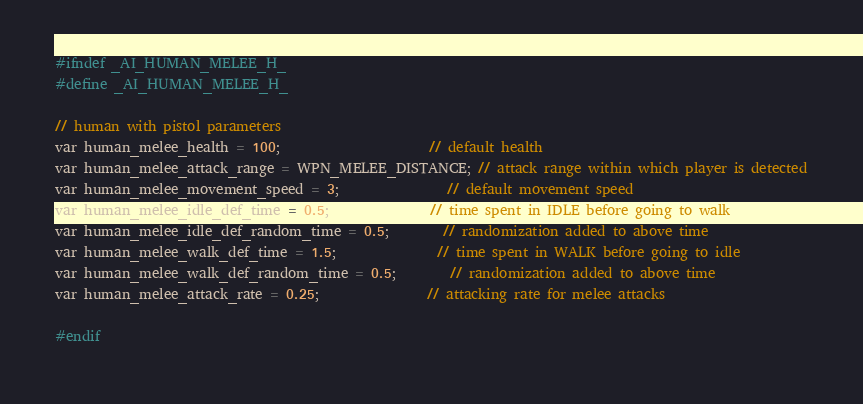Convert code to text. <code><loc_0><loc_0><loc_500><loc_500><_C_>#ifndef _AI_HUMAN_MELEE_H_
#define _AI_HUMAN_MELEE_H_

// human with pistol parameters
var human_melee_health = 100;                      // default health
var human_melee_attack_range = WPN_MELEE_DISTANCE; // attack range within which player is detected
var human_melee_movement_speed = 3;                // default movement speed
var human_melee_idle_def_time = 0.5;               // time spent in IDLE before going to walk
var human_melee_idle_def_random_time = 0.5;        // randomization added to above time
var human_melee_walk_def_time = 1.5;               // time spent in WALK before going to idle
var human_melee_walk_def_random_time = 0.5;        // randomization added to above time
var human_melee_attack_rate = 0.25;                // attacking rate for melee attacks

#endif</code> 